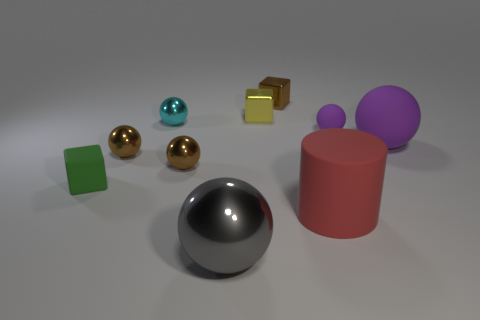What size is the object that is the same color as the large rubber sphere?
Keep it short and to the point. Small. There is a small object that is the same color as the large rubber ball; what is it made of?
Offer a terse response. Rubber. How many other things are there of the same color as the large rubber ball?
Your answer should be compact. 1. Is there a big shiny object of the same color as the cylinder?
Keep it short and to the point. No. What number of rubber things are tiny cyan objects or purple objects?
Your answer should be compact. 2. Are there any large red objects that have the same material as the small yellow thing?
Give a very brief answer. No. How many small objects are both to the left of the big red matte object and in front of the tiny brown block?
Provide a short and direct response. 5. Is the number of metallic blocks to the right of the large red object less than the number of matte cylinders behind the large matte sphere?
Your response must be concise. No. Is the large red rubber object the same shape as the cyan object?
Your answer should be compact. No. How many other objects are the same size as the cylinder?
Provide a succinct answer. 2. 